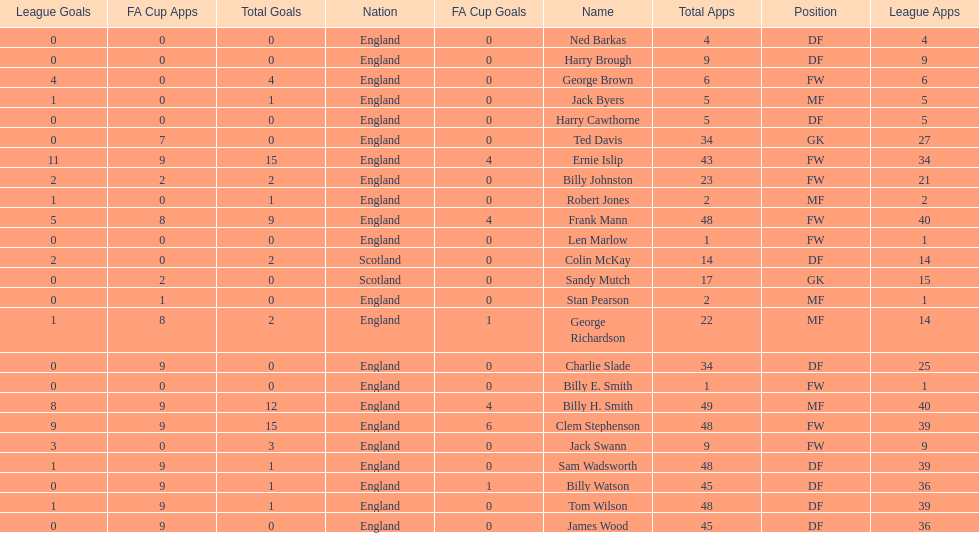The least number of total appearances 1. Parse the table in full. {'header': ['League Goals', 'FA Cup Apps', 'Total Goals', 'Nation', 'FA Cup Goals', 'Name', 'Total Apps', 'Position', 'League Apps'], 'rows': [['0', '0', '0', 'England', '0', 'Ned Barkas', '4', 'DF', '4'], ['0', '0', '0', 'England', '0', 'Harry Brough', '9', 'DF', '9'], ['4', '0', '4', 'England', '0', 'George Brown', '6', 'FW', '6'], ['1', '0', '1', 'England', '0', 'Jack Byers', '5', 'MF', '5'], ['0', '0', '0', 'England', '0', 'Harry Cawthorne', '5', 'DF', '5'], ['0', '7', '0', 'England', '0', 'Ted Davis', '34', 'GK', '27'], ['11', '9', '15', 'England', '4', 'Ernie Islip', '43', 'FW', '34'], ['2', '2', '2', 'England', '0', 'Billy Johnston', '23', 'FW', '21'], ['1', '0', '1', 'England', '0', 'Robert Jones', '2', 'MF', '2'], ['5', '8', '9', 'England', '4', 'Frank Mann', '48', 'FW', '40'], ['0', '0', '0', 'England', '0', 'Len Marlow', '1', 'FW', '1'], ['2', '0', '2', 'Scotland', '0', 'Colin McKay', '14', 'DF', '14'], ['0', '2', '0', 'Scotland', '0', 'Sandy Mutch', '17', 'GK', '15'], ['0', '1', '0', 'England', '0', 'Stan Pearson', '2', 'MF', '1'], ['1', '8', '2', 'England', '1', 'George Richardson', '22', 'MF', '14'], ['0', '9', '0', 'England', '0', 'Charlie Slade', '34', 'DF', '25'], ['0', '0', '0', 'England', '0', 'Billy E. Smith', '1', 'FW', '1'], ['8', '9', '12', 'England', '4', 'Billy H. Smith', '49', 'MF', '40'], ['9', '9', '15', 'England', '6', 'Clem Stephenson', '48', 'FW', '39'], ['3', '0', '3', 'England', '0', 'Jack Swann', '9', 'FW', '9'], ['1', '9', '1', 'England', '0', 'Sam Wadsworth', '48', 'DF', '39'], ['0', '9', '1', 'England', '1', 'Billy Watson', '45', 'DF', '36'], ['1', '9', '1', 'England', '0', 'Tom Wilson', '48', 'DF', '39'], ['0', '9', '0', 'England', '0', 'James Wood', '45', 'DF', '36']]} 